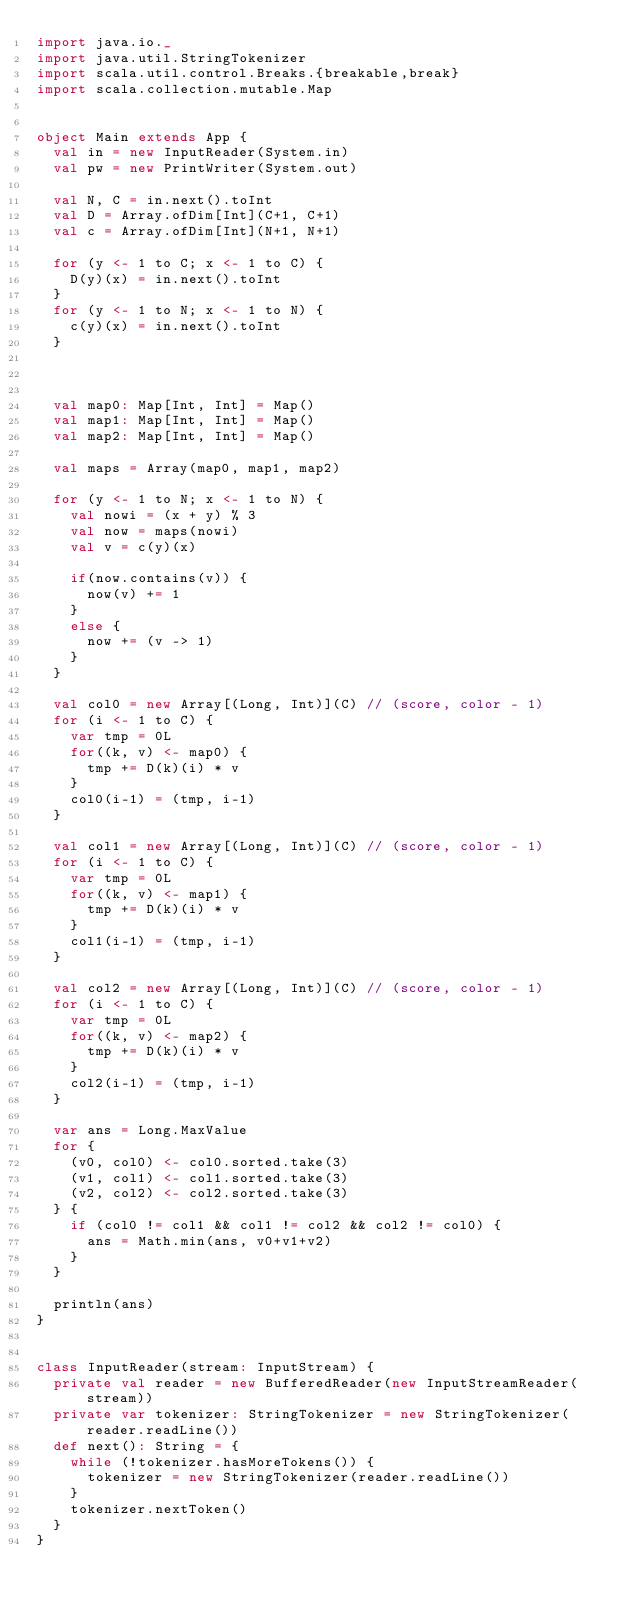<code> <loc_0><loc_0><loc_500><loc_500><_Scala_>import java.io._
import java.util.StringTokenizer
import scala.util.control.Breaks.{breakable,break}
import scala.collection.mutable.Map


object Main extends App {
  val in = new InputReader(System.in)
  val pw = new PrintWriter(System.out)

  val N, C = in.next().toInt
  val D = Array.ofDim[Int](C+1, C+1)
  val c = Array.ofDim[Int](N+1, N+1)

  for (y <- 1 to C; x <- 1 to C) {
    D(y)(x) = in.next().toInt
  }
  for (y <- 1 to N; x <- 1 to N) {
    c(y)(x) = in.next().toInt
  }



  val map0: Map[Int, Int] = Map()
  val map1: Map[Int, Int] = Map()
  val map2: Map[Int, Int] = Map()

  val maps = Array(map0, map1, map2)

  for (y <- 1 to N; x <- 1 to N) {
    val nowi = (x + y) % 3
    val now = maps(nowi)
    val v = c(y)(x)

    if(now.contains(v)) {
      now(v) += 1
    }
    else {
      now += (v -> 1)
    }
  }

  val col0 = new Array[(Long, Int)](C) // (score, color - 1)
  for (i <- 1 to C) {
    var tmp = 0L
    for((k, v) <- map0) {
      tmp += D(k)(i) * v
    }
    col0(i-1) = (tmp, i-1)
  }

  val col1 = new Array[(Long, Int)](C) // (score, color - 1)
  for (i <- 1 to C) {
    var tmp = 0L
    for((k, v) <- map1) {
      tmp += D(k)(i) * v
    }
    col1(i-1) = (tmp, i-1)
  }

  val col2 = new Array[(Long, Int)](C) // (score, color - 1)
  for (i <- 1 to C) {
    var tmp = 0L
    for((k, v) <- map2) {
      tmp += D(k)(i) * v
    }
    col2(i-1) = (tmp, i-1)
  }

  var ans = Long.MaxValue
  for {
    (v0, col0) <- col0.sorted.take(3)
    (v1, col1) <- col1.sorted.take(3)
    (v2, col2) <- col2.sorted.take(3)
  } {
    if (col0 != col1 && col1 != col2 && col2 != col0) {
      ans = Math.min(ans, v0+v1+v2)
    }
  }

  println(ans)
}


class InputReader(stream: InputStream) {
  private val reader = new BufferedReader(new InputStreamReader(stream))
  private var tokenizer: StringTokenizer = new StringTokenizer(reader.readLine())
  def next(): String = {
    while (!tokenizer.hasMoreTokens()) {
      tokenizer = new StringTokenizer(reader.readLine())
    }
    tokenizer.nextToken()
  }
}
</code> 